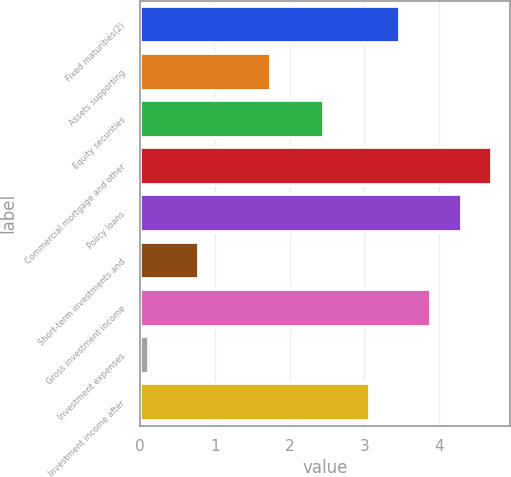<chart> <loc_0><loc_0><loc_500><loc_500><bar_chart><fcel>Fixed maturities(2)<fcel>Assets supporting<fcel>Equity securities<fcel>Commercial mortgage and other<fcel>Policy loans<fcel>Short-term investments and<fcel>Gross investment income<fcel>Investment expenses<fcel>Investment income after<nl><fcel>3.48<fcel>1.75<fcel>2.46<fcel>4.71<fcel>4.3<fcel>0.78<fcel>3.89<fcel>0.12<fcel>3.07<nl></chart> 